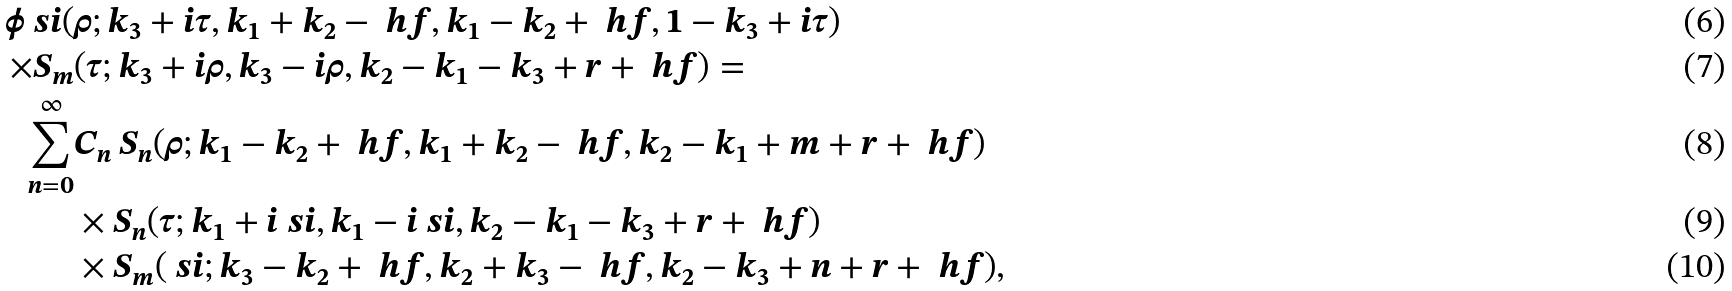Convert formula to latex. <formula><loc_0><loc_0><loc_500><loc_500>\phi _ { \ } s i ( & \rho ; k _ { 3 } + i \tau , k _ { 1 } + k _ { 2 } - \ h f , k _ { 1 } - k _ { 2 } + \ h f , 1 - k _ { 3 } + i \tau ) \\ \times S _ { m } & ( \tau ; k _ { 3 } + i \rho , k _ { 3 } - i \rho , k _ { 2 } - k _ { 1 } - k _ { 3 } + r + \ h f ) = \\ \sum _ { n = 0 } ^ { \infty } & C _ { n } \, S _ { n } ( \rho ; k _ { 1 } - k _ { 2 } + \ h f , k _ { 1 } + k _ { 2 } - \ h f , k _ { 2 } - k _ { 1 } + m + r + \ h f ) \\ & \times S _ { n } ( \tau ; k _ { 1 } + i \ s i , k _ { 1 } - i \ s i , k _ { 2 } - k _ { 1 } - k _ { 3 } + r + \ h f ) \\ & \times S _ { m } ( \ s i ; k _ { 3 } - k _ { 2 } + \ h f , k _ { 2 } + k _ { 3 } - \ h f , k _ { 2 } - k _ { 3 } + n + r + \ h f ) ,</formula> 